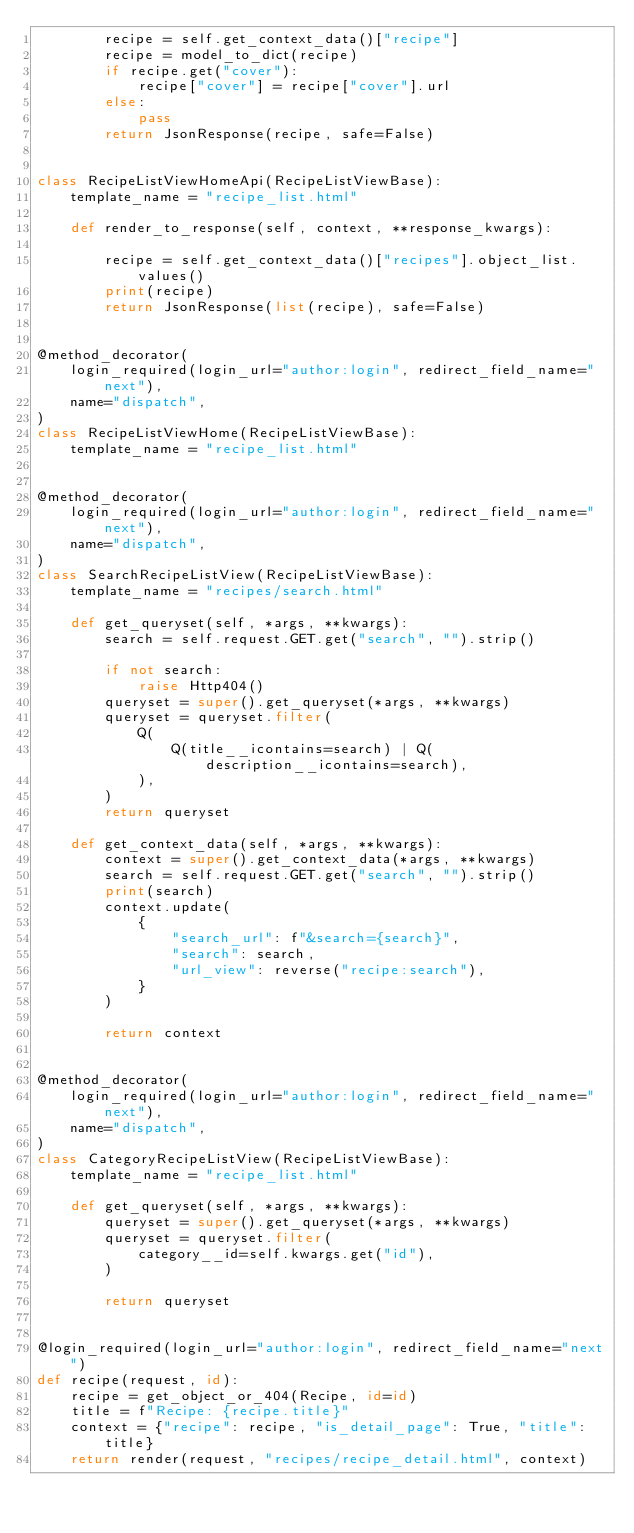<code> <loc_0><loc_0><loc_500><loc_500><_Python_>        recipe = self.get_context_data()["recipe"]
        recipe = model_to_dict(recipe)
        if recipe.get("cover"):
            recipe["cover"] = recipe["cover"].url
        else:
            pass
        return JsonResponse(recipe, safe=False)


class RecipeListViewHomeApi(RecipeListViewBase):
    template_name = "recipe_list.html"

    def render_to_response(self, context, **response_kwargs):

        recipe = self.get_context_data()["recipes"].object_list.values()
        print(recipe)
        return JsonResponse(list(recipe), safe=False)


@method_decorator(
    login_required(login_url="author:login", redirect_field_name="next"),
    name="dispatch",
)
class RecipeListViewHome(RecipeListViewBase):
    template_name = "recipe_list.html"


@method_decorator(
    login_required(login_url="author:login", redirect_field_name="next"),
    name="dispatch",
)
class SearchRecipeListView(RecipeListViewBase):
    template_name = "recipes/search.html"

    def get_queryset(self, *args, **kwargs):
        search = self.request.GET.get("search", "").strip()

        if not search:
            raise Http404()
        queryset = super().get_queryset(*args, **kwargs)
        queryset = queryset.filter(
            Q(
                Q(title__icontains=search) | Q(description__icontains=search),
            ),
        )
        return queryset

    def get_context_data(self, *args, **kwargs):
        context = super().get_context_data(*args, **kwargs)
        search = self.request.GET.get("search", "").strip()
        print(search)
        context.update(
            {
                "search_url": f"&search={search}",
                "search": search,
                "url_view": reverse("recipe:search"),
            }
        )

        return context


@method_decorator(
    login_required(login_url="author:login", redirect_field_name="next"),
    name="dispatch",
)
class CategoryRecipeListView(RecipeListViewBase):
    template_name = "recipe_list.html"

    def get_queryset(self, *args, **kwargs):
        queryset = super().get_queryset(*args, **kwargs)
        queryset = queryset.filter(
            category__id=self.kwargs.get("id"),
        )

        return queryset


@login_required(login_url="author:login", redirect_field_name="next")
def recipe(request, id):
    recipe = get_object_or_404(Recipe, id=id)
    title = f"Recipe: {recipe.title}"
    context = {"recipe": recipe, "is_detail_page": True, "title": title}
    return render(request, "recipes/recipe_detail.html", context)
</code> 